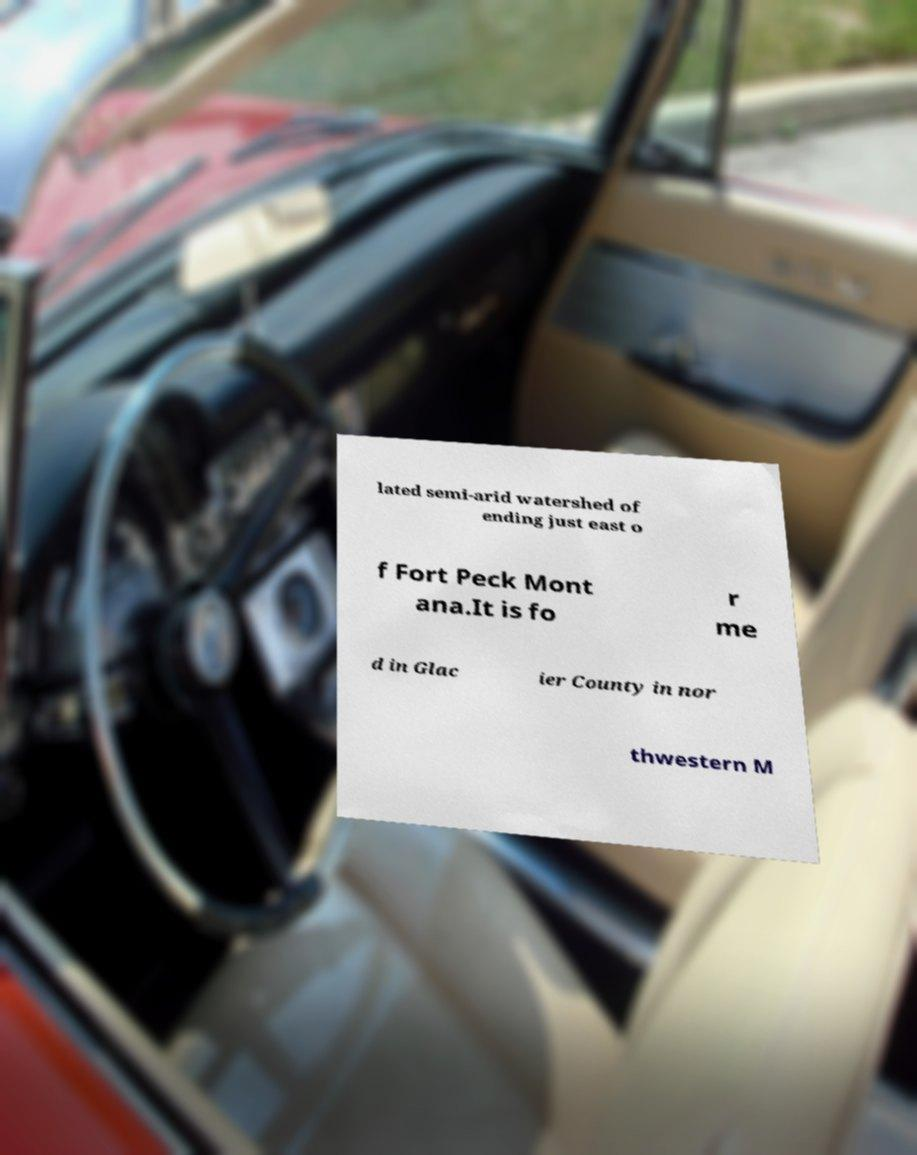Could you assist in decoding the text presented in this image and type it out clearly? lated semi-arid watershed of ending just east o f Fort Peck Mont ana.It is fo r me d in Glac ier County in nor thwestern M 